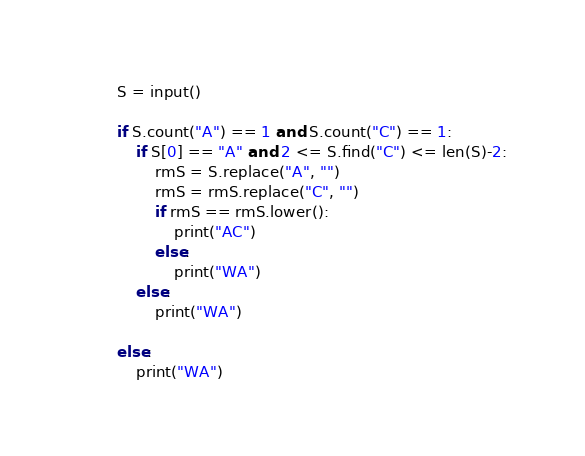<code> <loc_0><loc_0><loc_500><loc_500><_Python_>S = input()

if S.count("A") == 1 and S.count("C") == 1:
    if S[0] == "A" and 2 <= S.find("C") <= len(S)-2:
        rmS = S.replace("A", "")
        rmS = rmS.replace("C", "")
        if rmS == rmS.lower():
            print("AC")
        else:
            print("WA")
    else:
        print("WA")

else:
    print("WA")
</code> 